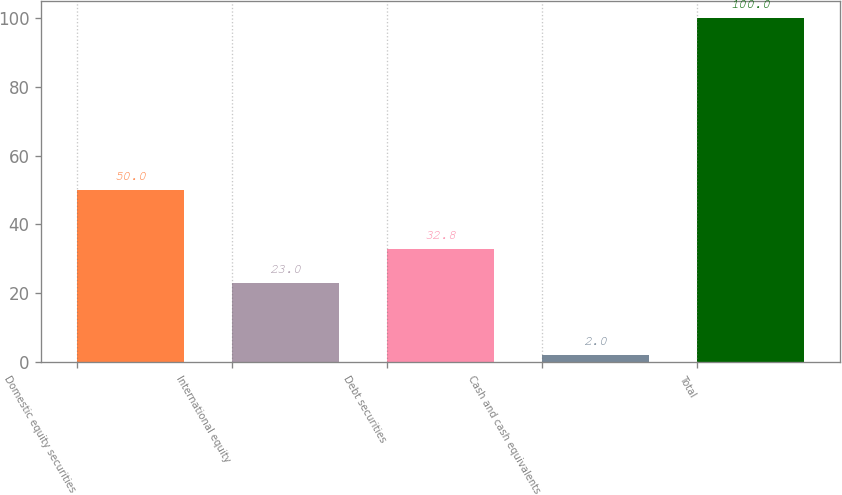Convert chart. <chart><loc_0><loc_0><loc_500><loc_500><bar_chart><fcel>Domestic equity securities<fcel>International equity<fcel>Debt securities<fcel>Cash and cash equivalents<fcel>Total<nl><fcel>50<fcel>23<fcel>32.8<fcel>2<fcel>100<nl></chart> 